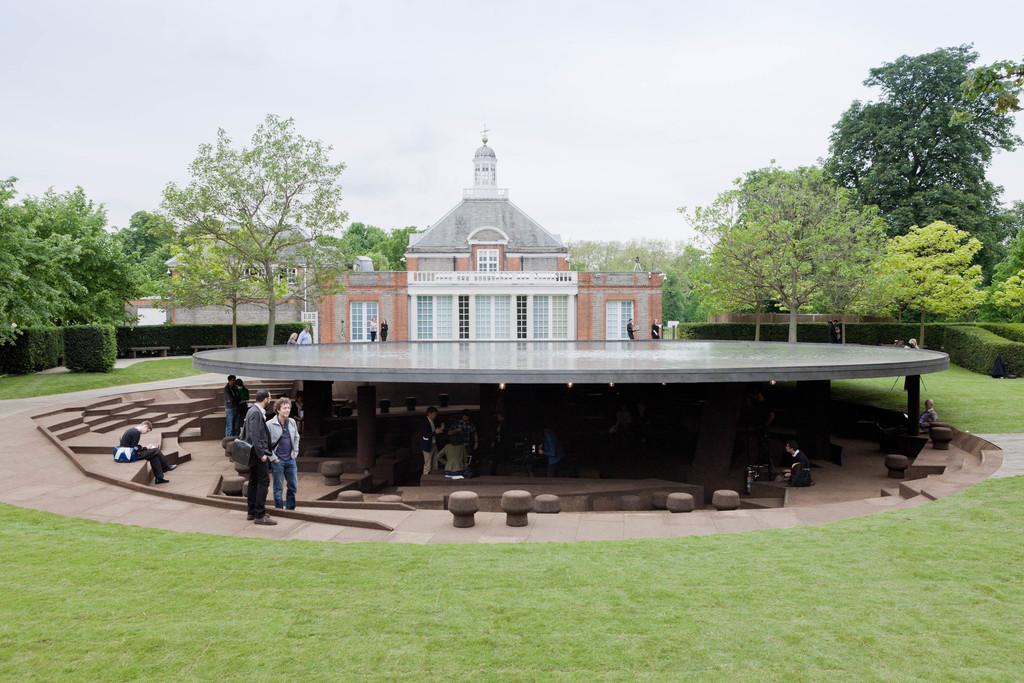In one or two sentences, can you explain what this image depicts? In the foreground of this image, there is grassland. In the middle, it seems like a shelter where people are under it. We can also see few are standing and few are sitting on the stairs. In the background, there is a building, shrubs, trees and the sky. 